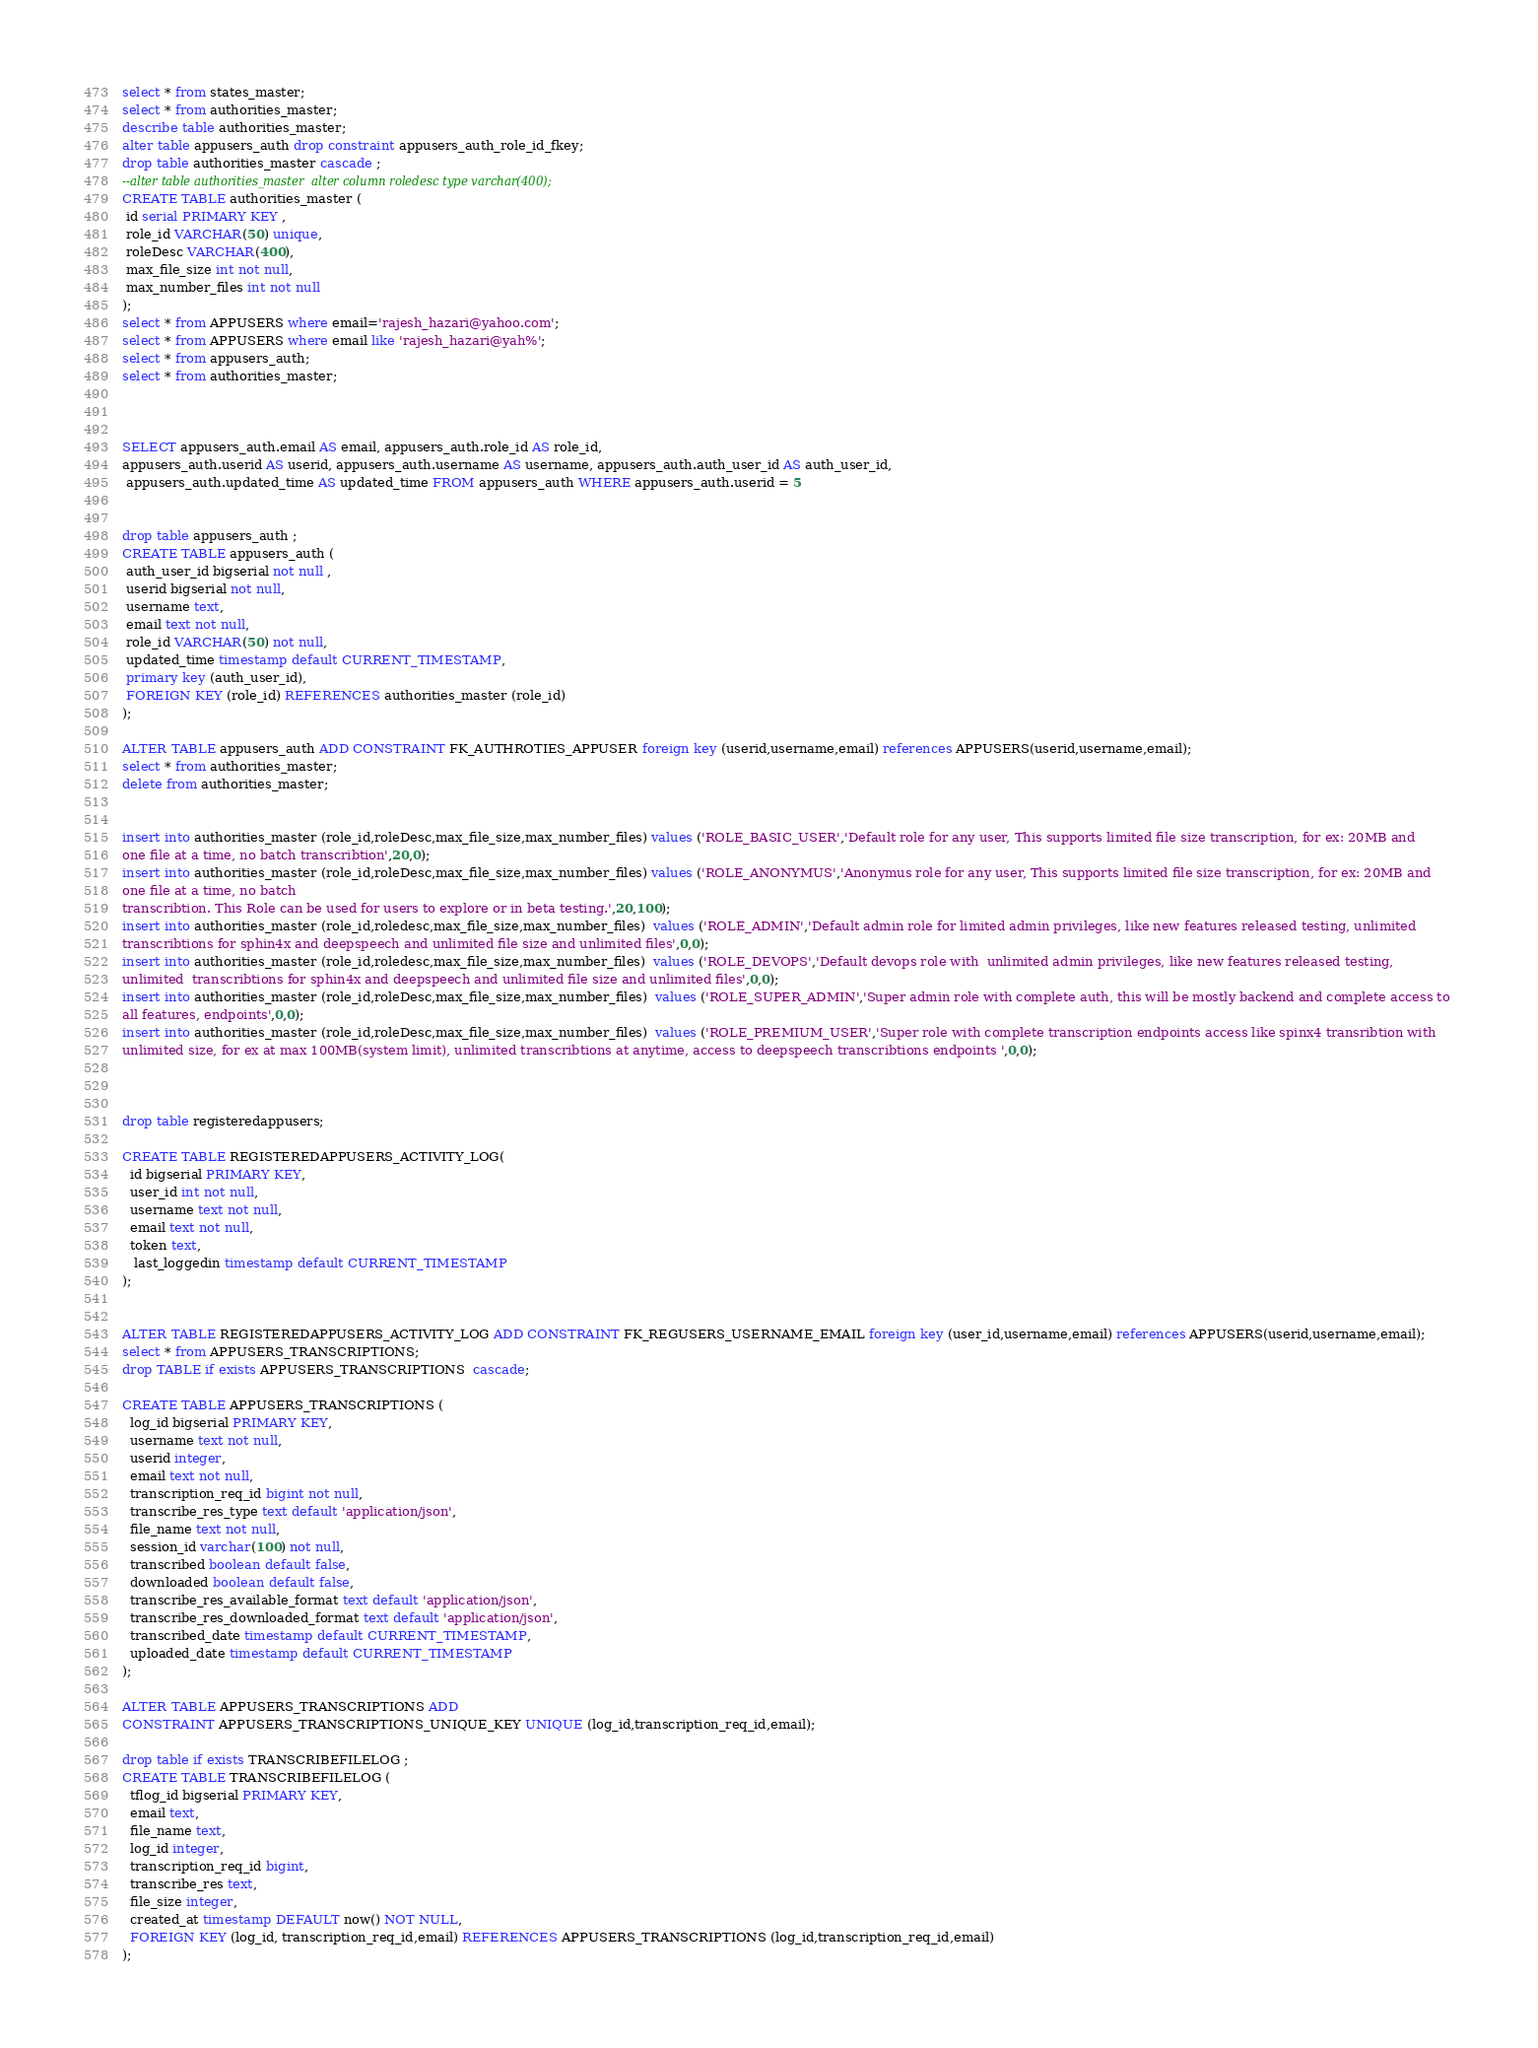<code> <loc_0><loc_0><loc_500><loc_500><_SQL_>
select * from states_master;
select * from authorities_master;
describe table authorities_master;
alter table appusers_auth drop constraint appusers_auth_role_id_fkey;
drop table authorities_master cascade ;
--alter table authorities_master  alter column roledesc type varchar(400);
CREATE TABLE authorities_master (
 id serial PRIMARY KEY ,
 role_id VARCHAR(50) unique,
 roleDesc VARCHAR(400),
 max_file_size int not null,
 max_number_files int not null
);
select * from APPUSERS where email='rajesh_hazari@yahoo.com';
select * from APPUSERS where email like 'rajesh_hazari@yah%';
select * from appusers_auth;
select * from authorities_master;


 
SELECT appusers_auth.email AS email, appusers_auth.role_id AS role_id, 
appusers_auth.userid AS userid, appusers_auth.username AS username, appusers_auth.auth_user_id AS auth_user_id,
 appusers_auth.updated_time AS updated_time FROM appusers_auth WHERE appusers_auth.userid = 5 


drop table appusers_auth ;
CREATE TABLE appusers_auth (
 auth_user_id bigserial not null ,
 userid bigserial not null,
 username text,
 email text not null,
 role_id VARCHAR(50) not null,
 updated_time timestamp default CURRENT_TIMESTAMP,
 primary key (auth_user_id),
 FOREIGN KEY (role_id) REFERENCES authorities_master (role_id)
);

ALTER TABLE appusers_auth ADD CONSTRAINT FK_AUTHROTIES_APPUSER foreign key (userid,username,email) references APPUSERS(userid,username,email);
select * from authorities_master;
delete from authorities_master;


insert into authorities_master (role_id,roleDesc,max_file_size,max_number_files) values ('ROLE_BASIC_USER','Default role for any user, This supports limited file size transcription, for ex: 20MB and 
one file at a time, no batch transcribtion',20,0);
insert into authorities_master (role_id,roleDesc,max_file_size,max_number_files) values ('ROLE_ANONYMUS','Anonymus role for any user, This supports limited file size transcription, for ex: 20MB and 
one file at a time, no batch 
transcribtion. This Role can be used for users to explore or in beta testing.',20,100);
insert into authorities_master (role_id,roledesc,max_file_size,max_number_files)  values ('ROLE_ADMIN','Default admin role for limited admin privileges, like new features released testing, unlimited 
transcribtions for sphin4x and deepspeech and unlimited file size and unlimited files',0,0);
insert into authorities_master (role_id,roledesc,max_file_size,max_number_files)  values ('ROLE_DEVOPS','Default devops role with  unlimited admin privileges, like new features released testing, 
unlimited  transcribtions for sphin4x and deepspeech and unlimited file size and unlimited files',0,0);
insert into authorities_master (role_id,roleDesc,max_file_size,max_number_files)  values ('ROLE_SUPER_ADMIN','Super admin role with complete auth, this will be mostly backend and complete access to 
all features, endpoints',0,0);
insert into authorities_master (role_id,roleDesc,max_file_size,max_number_files)  values ('ROLE_PREMIUM_USER','Super role with complete transcription endpoints access like spinx4 transribtion with 
unlimited size, for ex at max 100MB(system limit), unlimited transcribtions at anytime, access to deepspeech transcribtions endpoints ',0,0);



drop table registeredappusers;

CREATE TABLE REGISTEREDAPPUSERS_ACTIVITY_LOG(
  id bigserial PRIMARY KEY,
  user_id int not null,
  username text not null,
  email text not null,
  token text,
   last_loggedin timestamp default CURRENT_TIMESTAMP
);


ALTER TABLE REGISTEREDAPPUSERS_ACTIVITY_LOG ADD CONSTRAINT FK_REGUSERS_USERNAME_EMAIL foreign key (user_id,username,email) references APPUSERS(userid,username,email);
select * from APPUSERS_TRANSCRIPTIONS;
drop TABLE if exists APPUSERS_TRANSCRIPTIONS  cascade;

CREATE TABLE APPUSERS_TRANSCRIPTIONS (
  log_id bigserial PRIMARY KEY,
  username text not null,
  userid integer,
  email text not null,
  transcription_req_id bigint not null,
  transcribe_res_type text default 'application/json',
  file_name text not null,
  session_id varchar(100) not null,
  transcribed boolean default false,
  downloaded boolean default false,
  transcribe_res_available_format text default 'application/json',
  transcribe_res_downloaded_format text default 'application/json',
  transcribed_date timestamp default CURRENT_TIMESTAMP,
  uploaded_date timestamp default CURRENT_TIMESTAMP
);

ALTER TABLE APPUSERS_TRANSCRIPTIONS ADD
CONSTRAINT APPUSERS_TRANSCRIPTIONS_UNIQUE_KEY UNIQUE (log_id,transcription_req_id,email);

drop table if exists TRANSCRIBEFILELOG ;
CREATE TABLE TRANSCRIBEFILELOG (
  tflog_id bigserial PRIMARY KEY,
  email text,
  file_name text,
  log_id integer,
  transcription_req_id bigint,
  transcribe_res text,
  file_size integer,
  created_at timestamp DEFAULT now() NOT NULL,
  FOREIGN KEY (log_id, transcription_req_id,email) REFERENCES APPUSERS_TRANSCRIPTIONS (log_id,transcription_req_id,email)
);
</code> 